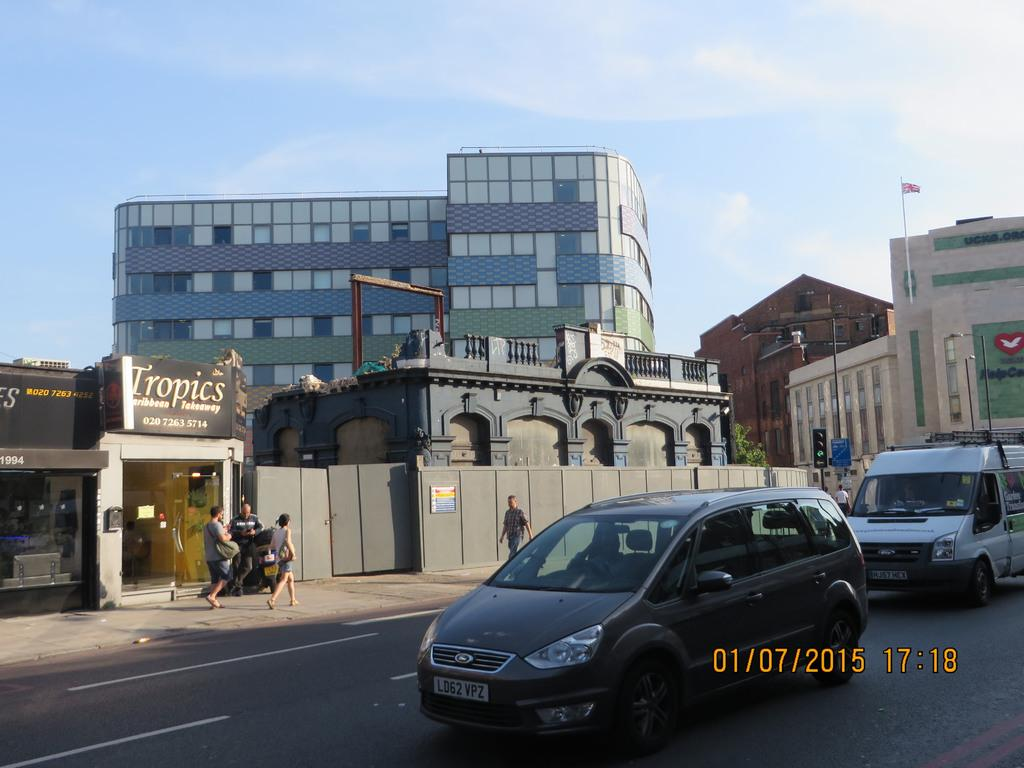What can be seen on the road in the image? There are vehicles on the road in the image. What is visible in the background of the image? Buildings, people, flagpoles, the sky, and traffic lights can be seen in the background of the image. What other objects are present in the background of the image? There are other objects in the background of the image, but their specific details are not mentioned in the provided facts. Is there any indication of a watermark in the image? Yes, there is a watermark in the image. Can you tell me how many times the word "fact" appears in the image? The word "fact" is not mentioned in the provided facts, and therefore it cannot be determined how many times it appears in the image. Is there a can visible in the image? There is no mention of a can in the provided facts, and therefore it cannot be determined if one is present in the image. 